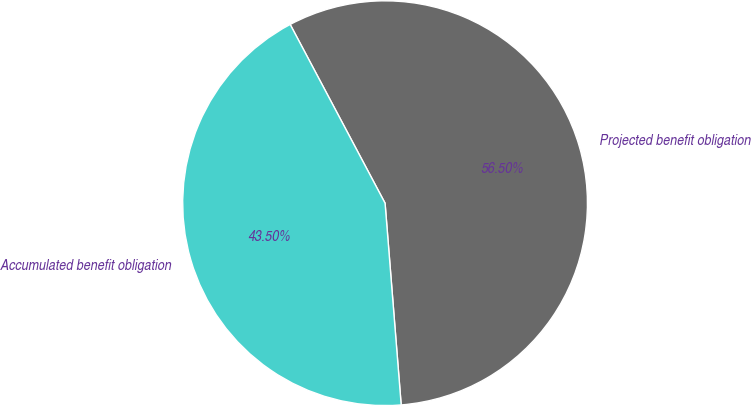Convert chart. <chart><loc_0><loc_0><loc_500><loc_500><pie_chart><fcel>Projected benefit obligation<fcel>Accumulated benefit obligation<nl><fcel>56.5%<fcel>43.5%<nl></chart> 